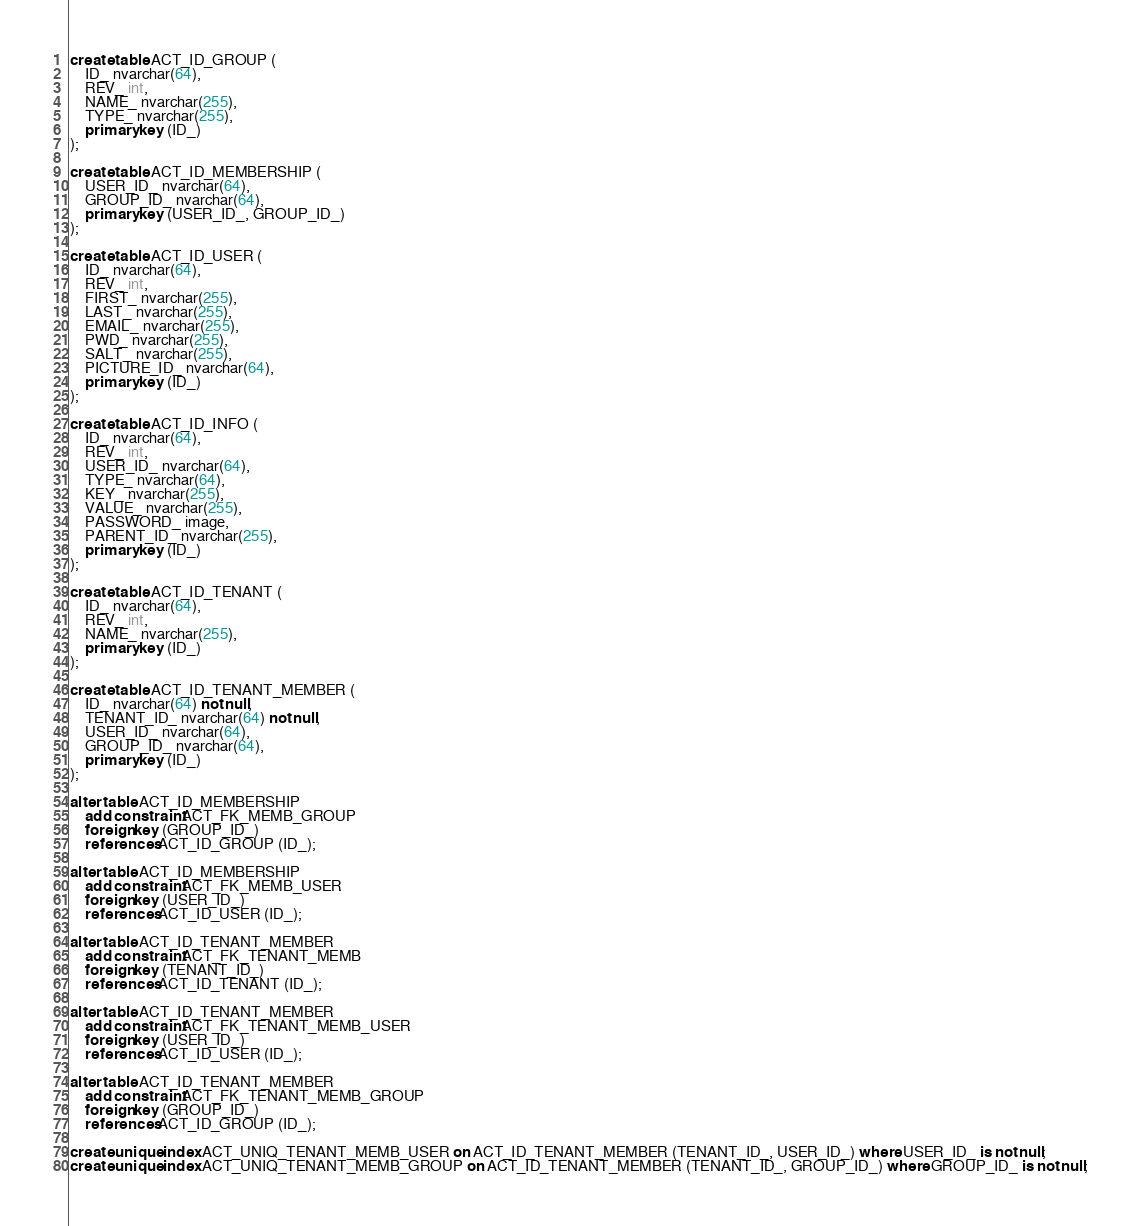<code> <loc_0><loc_0><loc_500><loc_500><_SQL_>create table ACT_ID_GROUP (
    ID_ nvarchar(64),
    REV_ int,
    NAME_ nvarchar(255),
    TYPE_ nvarchar(255),
    primary key (ID_)
);

create table ACT_ID_MEMBERSHIP (
    USER_ID_ nvarchar(64),
    GROUP_ID_ nvarchar(64),
    primary key (USER_ID_, GROUP_ID_)
);

create table ACT_ID_USER (
    ID_ nvarchar(64),
    REV_ int,
    FIRST_ nvarchar(255),
    LAST_ nvarchar(255),
    EMAIL_ nvarchar(255),
    PWD_ nvarchar(255),
    SALT_ nvarchar(255),
    PICTURE_ID_ nvarchar(64),
    primary key (ID_)
);

create table ACT_ID_INFO (
    ID_ nvarchar(64),
    REV_ int,
    USER_ID_ nvarchar(64),
    TYPE_ nvarchar(64),
    KEY_ nvarchar(255),
    VALUE_ nvarchar(255),
    PASSWORD_ image,
    PARENT_ID_ nvarchar(255),
    primary key (ID_)
);

create table ACT_ID_TENANT (
    ID_ nvarchar(64),
    REV_ int,
    NAME_ nvarchar(255),
    primary key (ID_)
);

create table ACT_ID_TENANT_MEMBER (
    ID_ nvarchar(64) not null,
    TENANT_ID_ nvarchar(64) not null,
    USER_ID_ nvarchar(64),
    GROUP_ID_ nvarchar(64),
    primary key (ID_)
);

alter table ACT_ID_MEMBERSHIP
    add constraint ACT_FK_MEMB_GROUP
    foreign key (GROUP_ID_)
    references ACT_ID_GROUP (ID_);

alter table ACT_ID_MEMBERSHIP
    add constraint ACT_FK_MEMB_USER
    foreign key (USER_ID_)
    references ACT_ID_USER (ID_);

alter table ACT_ID_TENANT_MEMBER
    add constraint ACT_FK_TENANT_MEMB
    foreign key (TENANT_ID_)
    references ACT_ID_TENANT (ID_);

alter table ACT_ID_TENANT_MEMBER
    add constraint ACT_FK_TENANT_MEMB_USER
    foreign key (USER_ID_)
    references ACT_ID_USER (ID_);

alter table ACT_ID_TENANT_MEMBER
    add constraint ACT_FK_TENANT_MEMB_GROUP
    foreign key (GROUP_ID_)
    references ACT_ID_GROUP (ID_);

create unique index ACT_UNIQ_TENANT_MEMB_USER on ACT_ID_TENANT_MEMBER (TENANT_ID_, USER_ID_) where USER_ID_ is not null;
create unique index ACT_UNIQ_TENANT_MEMB_GROUP on ACT_ID_TENANT_MEMBER (TENANT_ID_, GROUP_ID_) where GROUP_ID_ is not null;
</code> 